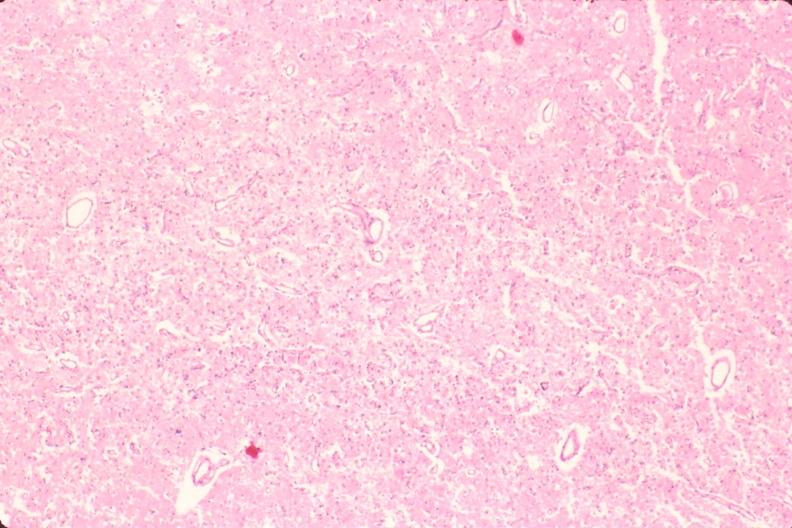s thymus present?
Answer the question using a single word or phrase. No 